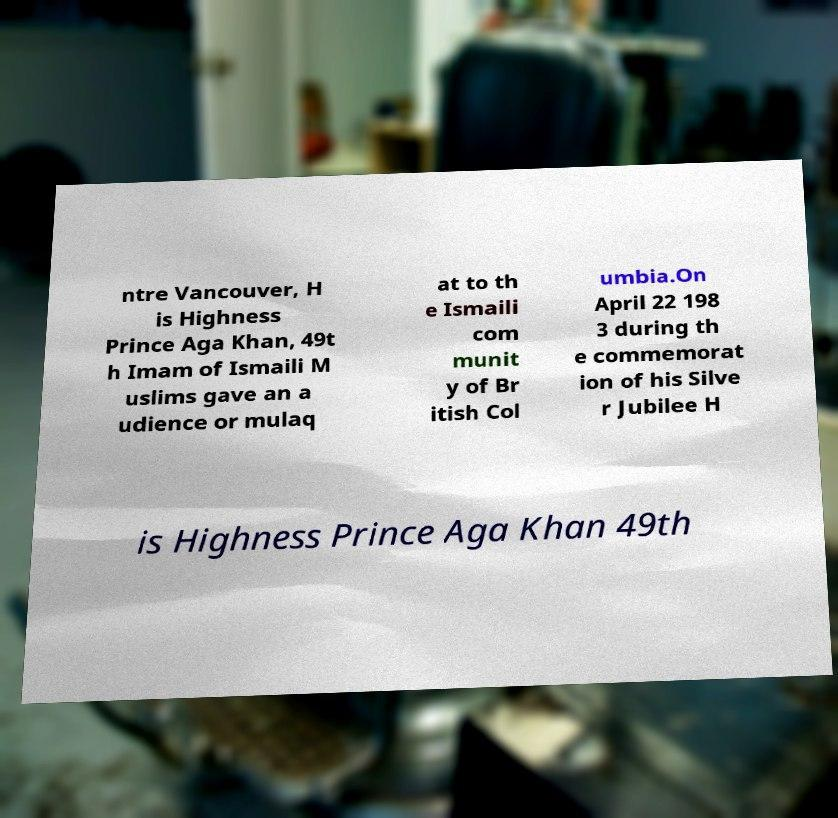There's text embedded in this image that I need extracted. Can you transcribe it verbatim? ntre Vancouver, H is Highness Prince Aga Khan, 49t h Imam of Ismaili M uslims gave an a udience or mulaq at to th e Ismaili com munit y of Br itish Col umbia.On April 22 198 3 during th e commemorat ion of his Silve r Jubilee H is Highness Prince Aga Khan 49th 